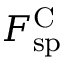Convert formula to latex. <formula><loc_0><loc_0><loc_500><loc_500>F _ { s p } ^ { C }</formula> 